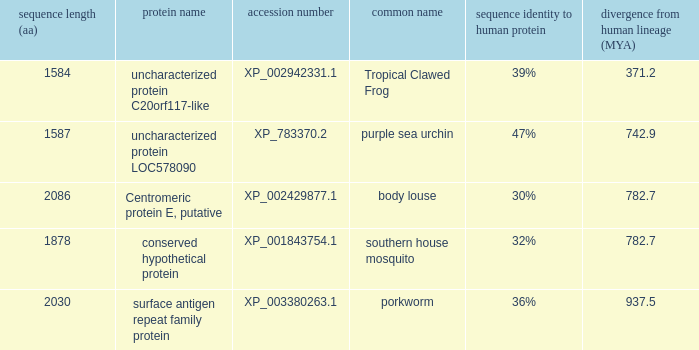What is the accession number of the protein with a divergence from human lineage of 937.5? XP_003380263.1. Write the full table. {'header': ['sequence length (aa)', 'protein name', 'accession number', 'common name', 'sequence identity to human protein', 'divergence from human lineage (MYA)'], 'rows': [['1584', 'uncharacterized protein C20orf117-like', 'XP_002942331.1', 'Tropical Clawed Frog', '39%', '371.2'], ['1587', 'uncharacterized protein LOC578090', 'XP_783370.2', 'purple sea urchin', '47%', '742.9'], ['2086', 'Centromeric protein E, putative', 'XP_002429877.1', 'body louse', '30%', '782.7'], ['1878', 'conserved hypothetical protein', 'XP_001843754.1', 'southern house mosquito', '32%', '782.7'], ['2030', 'surface antigen repeat family protein', 'XP_003380263.1', 'porkworm', '36%', '937.5']]} 